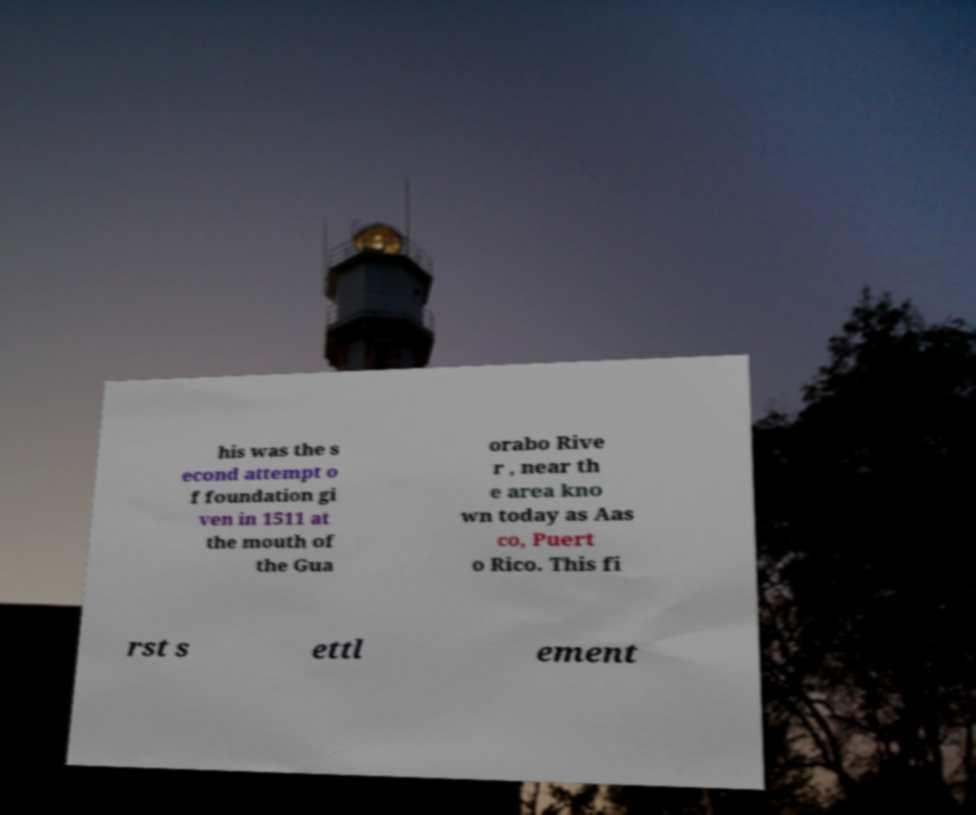Please identify and transcribe the text found in this image. his was the s econd attempt o f foundation gi ven in 1511 at the mouth of the Gua orabo Rive r , near th e area kno wn today as Aas co, Puert o Rico. This fi rst s ettl ement 